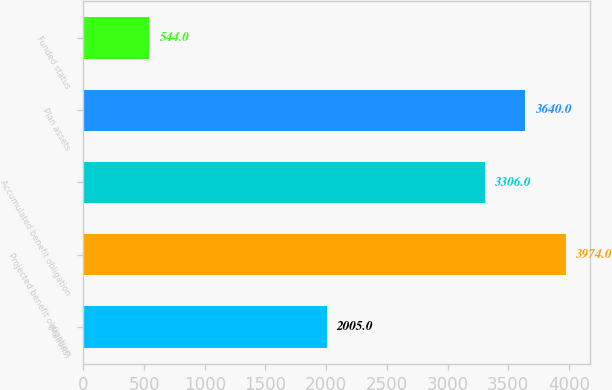Convert chart to OTSL. <chart><loc_0><loc_0><loc_500><loc_500><bar_chart><fcel>(Millions)<fcel>Projected benefit obligation<fcel>Accumulated benefit obligation<fcel>Plan assets<fcel>Funded status<nl><fcel>2005<fcel>3974<fcel>3306<fcel>3640<fcel>544<nl></chart> 